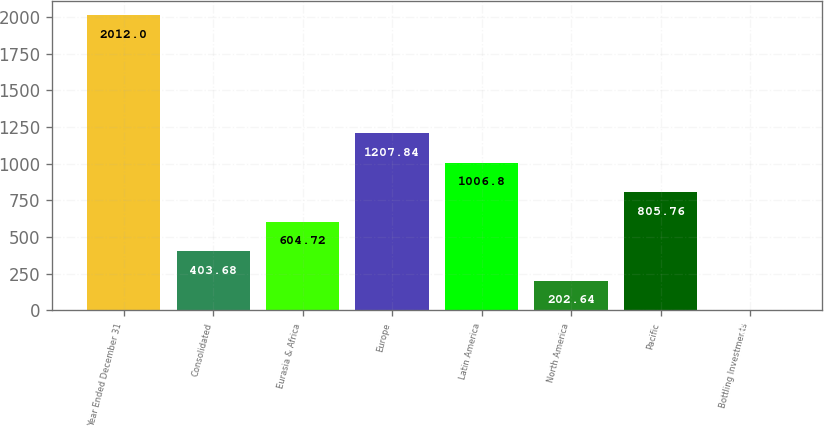Convert chart to OTSL. <chart><loc_0><loc_0><loc_500><loc_500><bar_chart><fcel>Year Ended December 31<fcel>Consolidated<fcel>Eurasia & Africa<fcel>Europe<fcel>Latin America<fcel>North America<fcel>Pacific<fcel>Bottling Investments<nl><fcel>2012<fcel>403.68<fcel>604.72<fcel>1207.84<fcel>1006.8<fcel>202.64<fcel>805.76<fcel>1.6<nl></chart> 